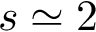<formula> <loc_0><loc_0><loc_500><loc_500>s \simeq 2</formula> 